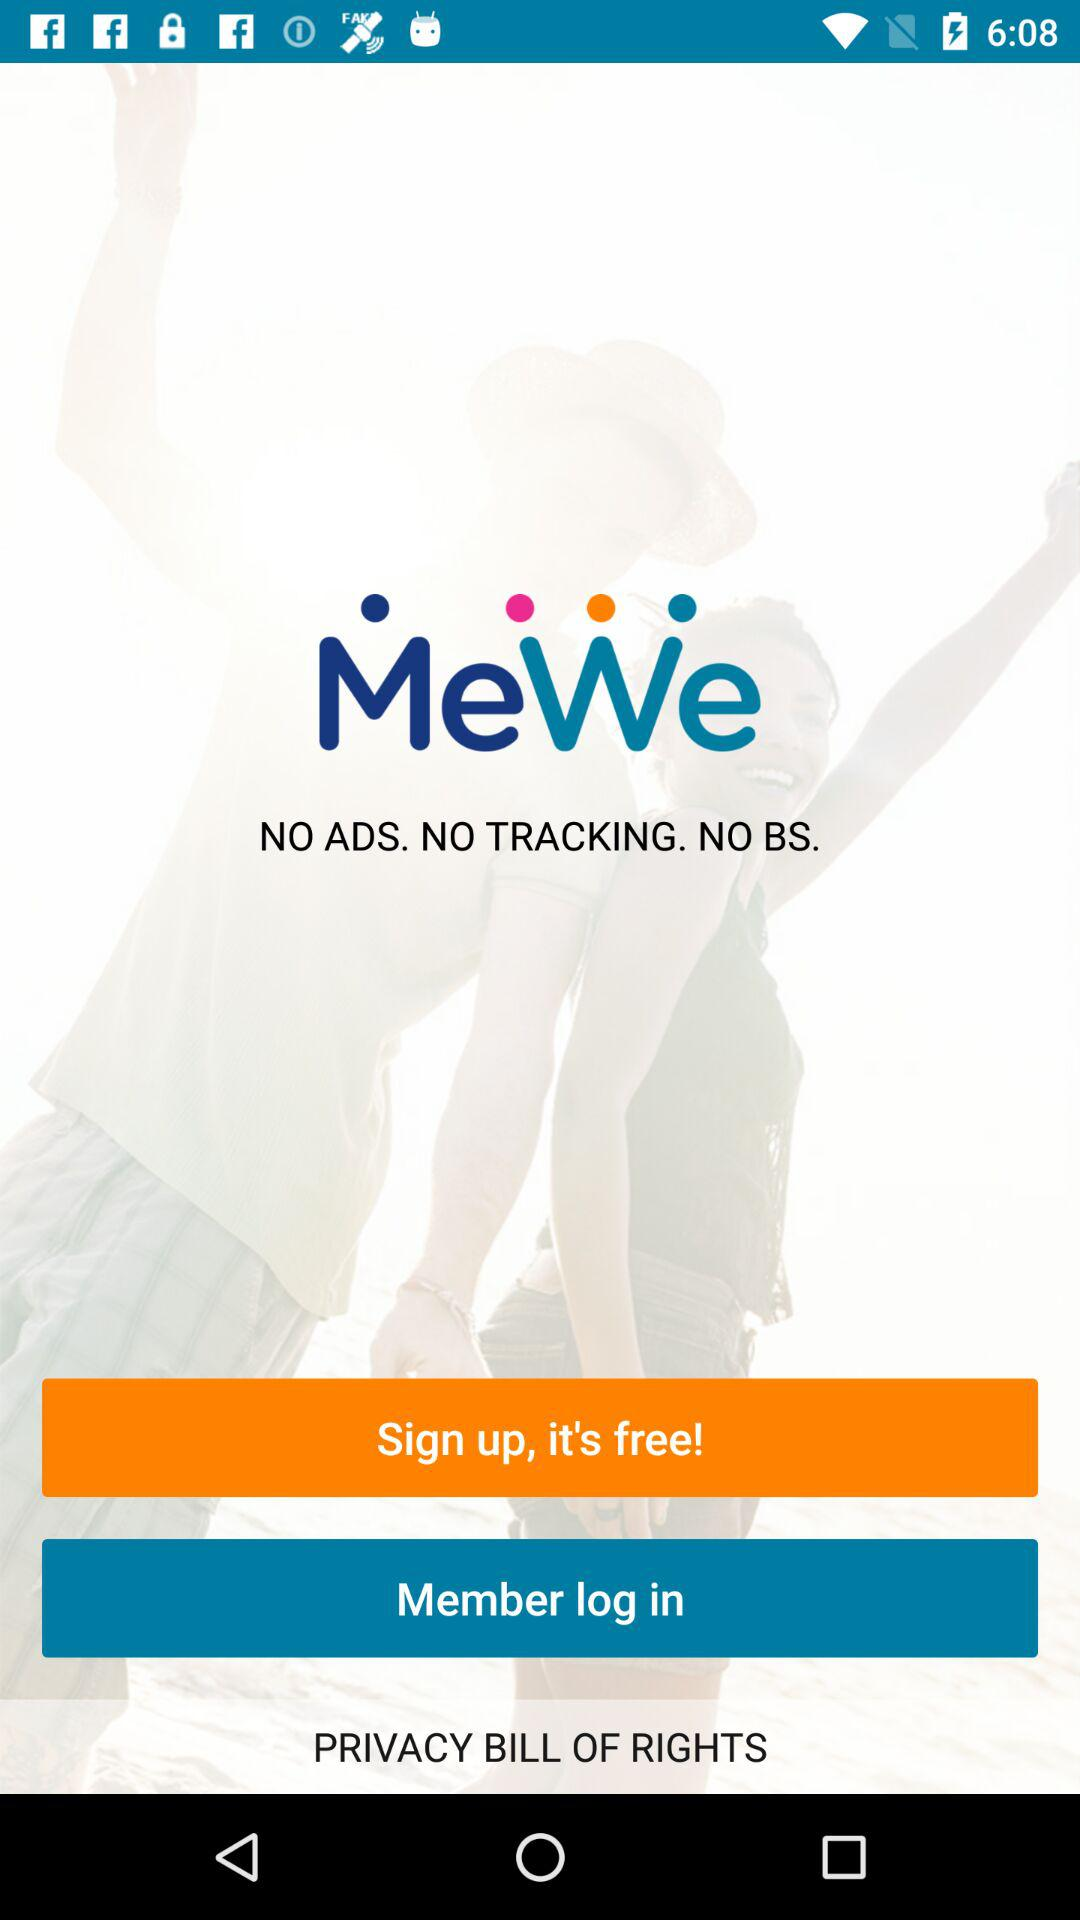What is the name of the application? The name of the application is "MeWe". 